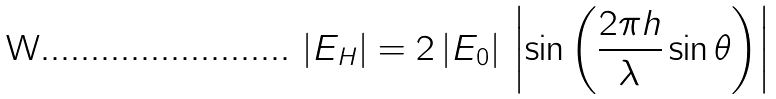<formula> <loc_0><loc_0><loc_500><loc_500>\left | E _ { H } \right | = 2 \left | E _ { 0 } \right | \, \left | \sin \left ( { \frac { 2 \pi h } { \lambda } } \sin \theta \right ) \right |</formula> 